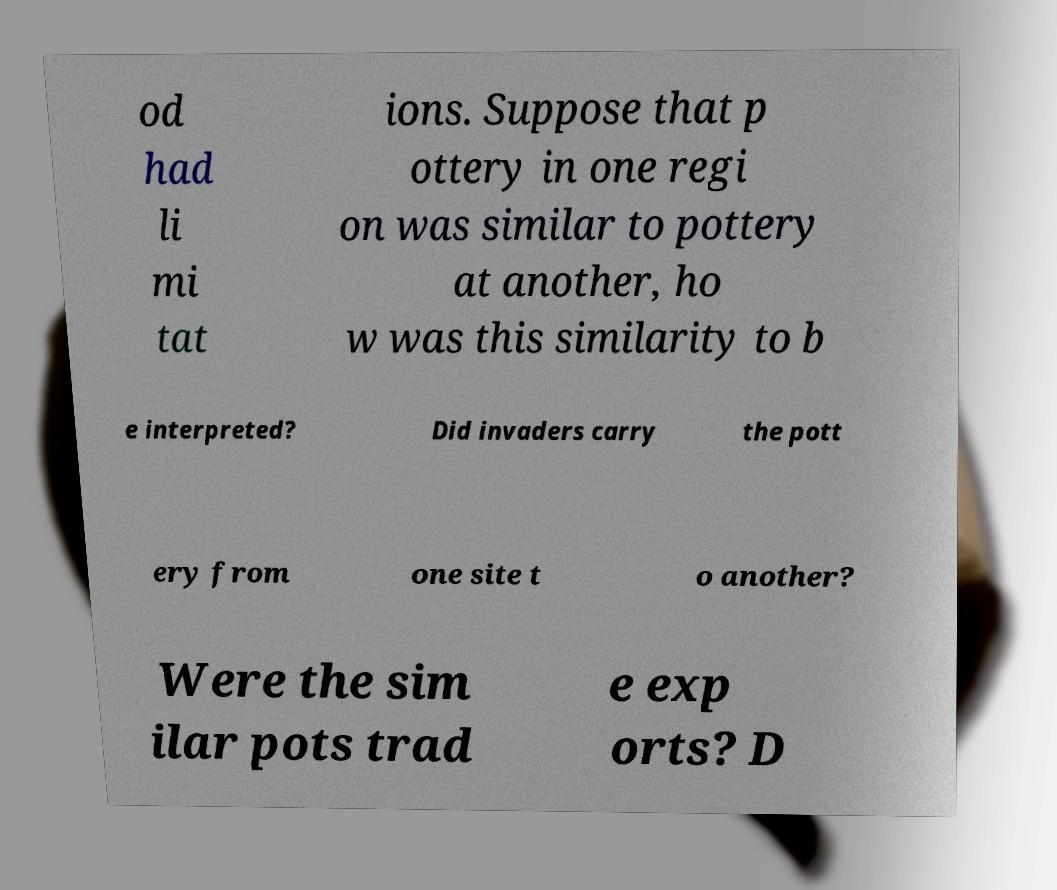For documentation purposes, I need the text within this image transcribed. Could you provide that? od had li mi tat ions. Suppose that p ottery in one regi on was similar to pottery at another, ho w was this similarity to b e interpreted? Did invaders carry the pott ery from one site t o another? Were the sim ilar pots trad e exp orts? D 